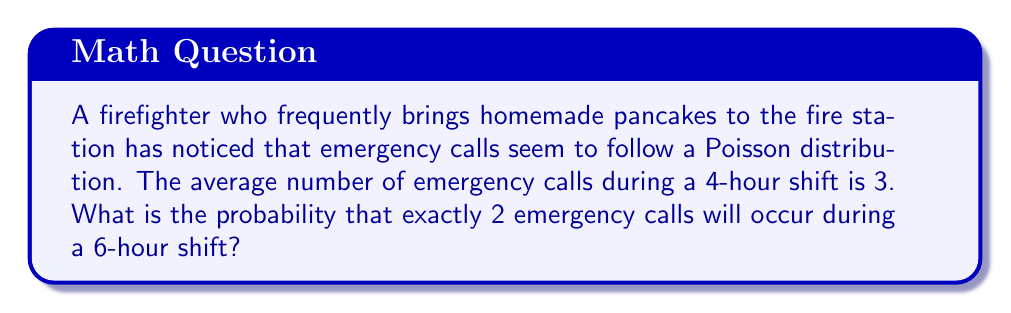Solve this math problem. To solve this problem, we need to use the Poisson distribution formula and adjust the parameter λ (lambda) for the given time interval. Let's break it down step-by-step:

1) The Poisson distribution formula is:

   $$P(X = k) = \frac{e^{-\lambda} \lambda^k}{k!}$$

   where λ is the average number of events in the interval, and k is the number of events we're interested in.

2) We're given that the average number of calls in a 4-hour shift is 3. Let's call this λ₄.
   
   λ₄ = 3

3) We need to find λ₆, the average number of calls in a 6-hour shift. Since the Poisson process is assumed to be uniform over time, we can use proportions:

   $$\frac{\lambda_6}{6} = \frac{\lambda_4}{4}$$

   $$\lambda_6 = \frac{6 \lambda_4}{4} = \frac{6 * 3}{4} = 4.5$$

4) Now we have λ = 4.5 for our 6-hour shift. We want to find the probability of exactly 2 calls (k = 2).

5) Plugging into the Poisson formula:

   $$P(X = 2) = \frac{e^{-4.5} 4.5^2}{2!}$$

6) Calculating:
   
   $$P(X = 2) = \frac{e^{-4.5} * 20.25}{2} \approx 0.1281$$

7) Convert to a percentage:

   0.1281 * 100 ≈ 12.81%
Answer: The probability of exactly 2 emergency calls occurring during a 6-hour shift is approximately 12.81%. 